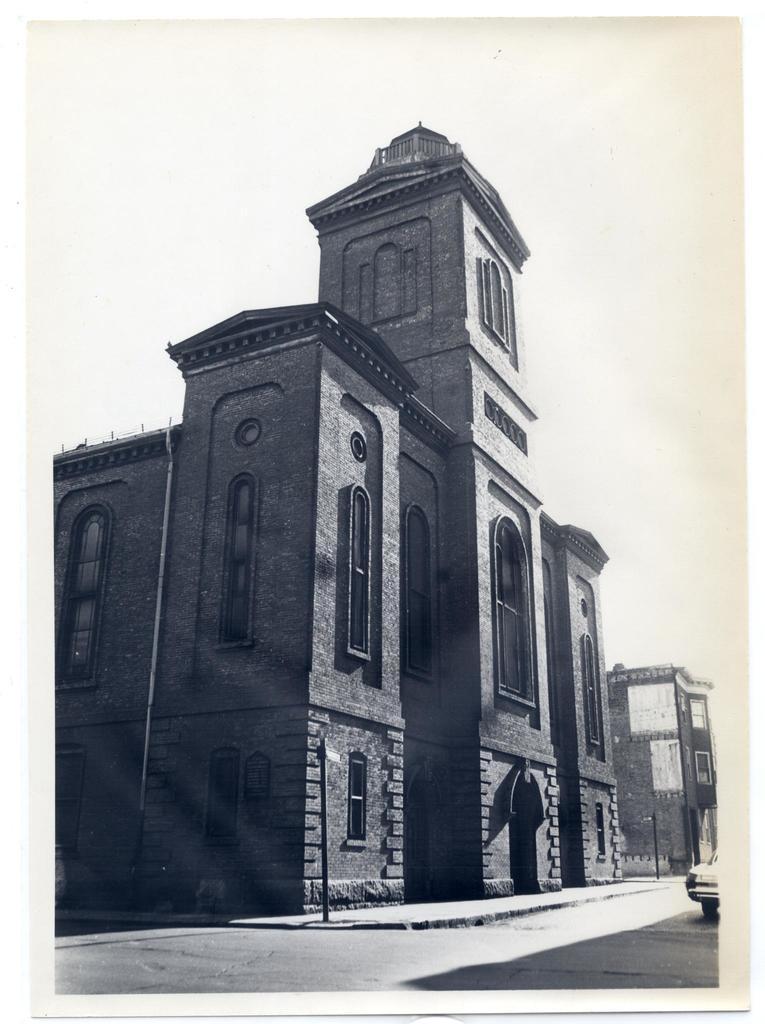Describe this image in one or two sentences. In this image I can see a building , in front of building I can see a road, on the road I can see a vehicle, at the top I can see the sky. 